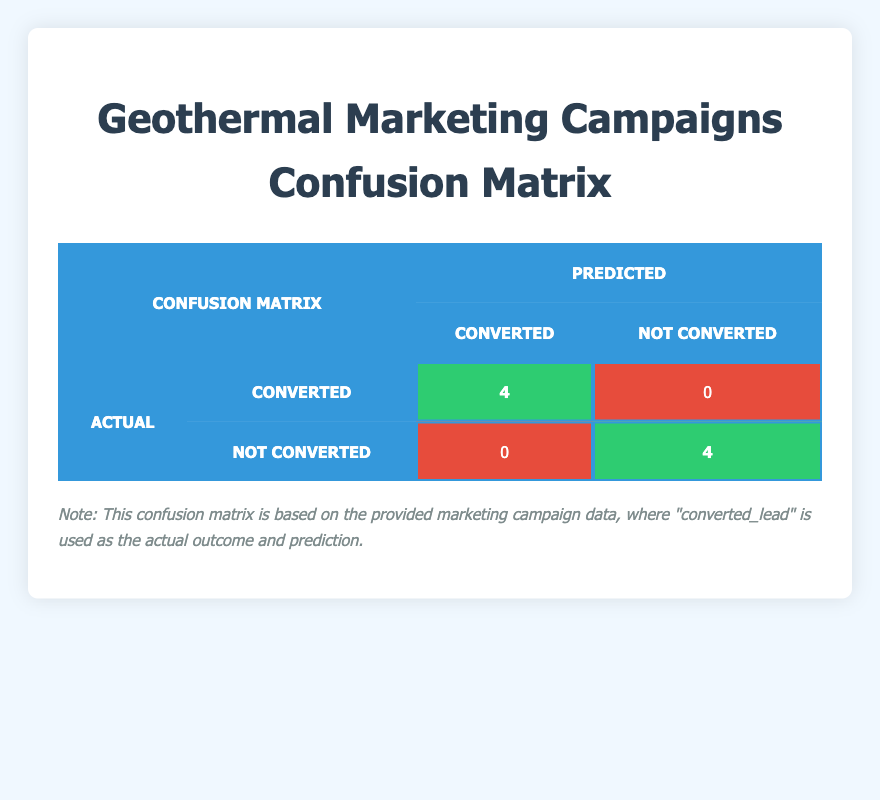What is the total number of campaigns that resulted in converted leads? From the confusion matrix, it shows that there were 4 actual converted leads (the value in the "Converted" row and "Converted" column). This is directly visible in the table.
Answer: 4 How many campaigns did not result in converted leads? The confusion matrix indicates that there are 4 campaigns under the "Not Converted" row and "Not Converted" column. This is also visible in the table.
Answer: 4 Is it true that there were no false positives in the marketing campaigns? Looking at the table, there are not any cases labeled as "False Positive," which would appear in the "Not Converted" row and "Converted" column. Thus, it is true.
Answer: Yes What is the ratio of converted leads to not converted leads? According to the table, there are 4 converted leads and 4 not converted leads. Therefore, the ratio is 4:4, which simplifies to 1:1.
Answer: 1:1 Which campaigns had the highest engagement score among converted leads? The highest engagement score among the converted leads is 90 from the "Renewable Energy Expo" campaign. This is found by comparing the engagement scores of the campaigns labeled as converted.
Answer: 90 What is the engagement score of the campaign that resulted in the lowest conversion? The campaign with no converted leads is "Local Business Green Initiative," which has an engagement score of 45. This information can be gleaned from the "Not Converted" row in the table.
Answer: 45 Is there any campaign that had a follow-up contacted but did not convert? Yes, the "Sustainable Solutions Showcase," "Eco-Friendly Business Program," and "Green Energy Workshop" all had follow-ups contacted, yet did not result in a conversion, as indicated in the provided campaign data.
Answer: Yes How many campaigns had both follow-up contacted and resulted in no conversion? There are two campaigns listed in the data, which include "Sustainable Solutions Showcase" and "Eco-Friendly Business Program." Both had follow-ups contacted yet did not convert. This can be calculated by filtering the relevant campaigns in the dataset.
Answer: 2 Which campaign had a conversion status but did not have a follow-up contacted? The "Clean Geothermal Future" campaign had a conversion status of true but did not have follow-up contact, as shown in the data table.
Answer: Clean Geothermal Future 